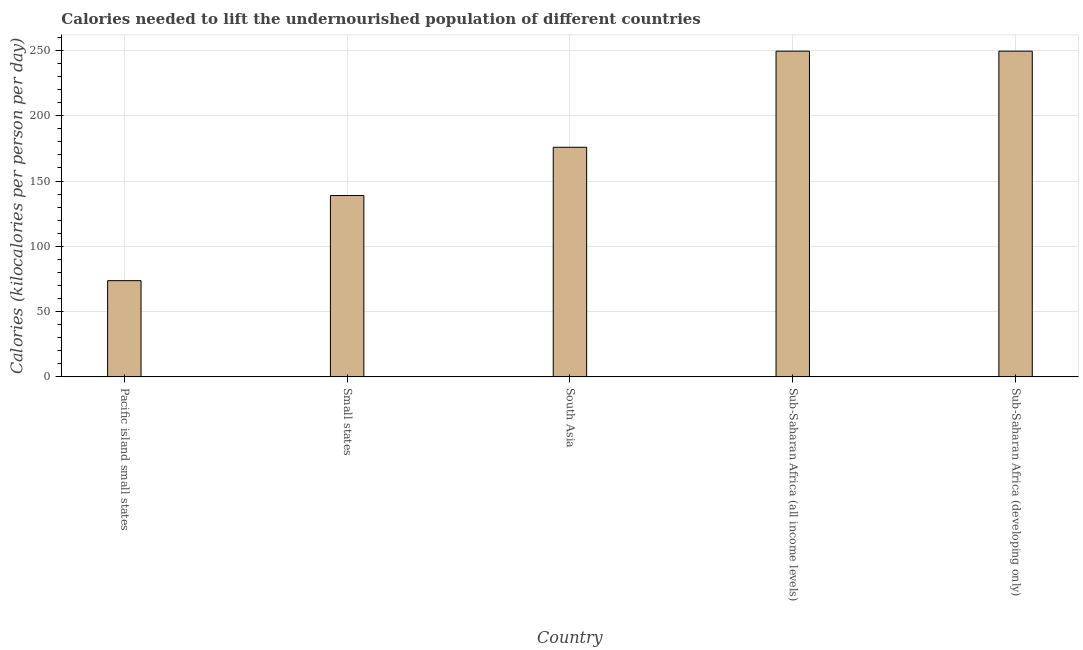Does the graph contain grids?
Your answer should be very brief. Yes. What is the title of the graph?
Your answer should be compact. Calories needed to lift the undernourished population of different countries. What is the label or title of the X-axis?
Provide a succinct answer. Country. What is the label or title of the Y-axis?
Offer a very short reply. Calories (kilocalories per person per day). What is the depth of food deficit in Pacific island small states?
Keep it short and to the point. 73.68. Across all countries, what is the maximum depth of food deficit?
Give a very brief answer. 249.45. Across all countries, what is the minimum depth of food deficit?
Give a very brief answer. 73.68. In which country was the depth of food deficit maximum?
Your answer should be compact. Sub-Saharan Africa (all income levels). In which country was the depth of food deficit minimum?
Give a very brief answer. Pacific island small states. What is the sum of the depth of food deficit?
Give a very brief answer. 887.31. What is the difference between the depth of food deficit in Pacific island small states and South Asia?
Provide a succinct answer. -102.16. What is the average depth of food deficit per country?
Give a very brief answer. 177.46. What is the median depth of food deficit?
Your response must be concise. 175.85. What is the ratio of the depth of food deficit in Pacific island small states to that in Sub-Saharan Africa (developing only)?
Offer a very short reply. 0.29. Is the depth of food deficit in South Asia less than that in Sub-Saharan Africa (all income levels)?
Keep it short and to the point. Yes. Is the difference between the depth of food deficit in Small states and Sub-Saharan Africa (developing only) greater than the difference between any two countries?
Keep it short and to the point. No. What is the difference between the highest and the second highest depth of food deficit?
Offer a terse response. 0. What is the difference between the highest and the lowest depth of food deficit?
Provide a short and direct response. 175.77. In how many countries, is the depth of food deficit greater than the average depth of food deficit taken over all countries?
Your answer should be very brief. 2. How many bars are there?
Make the answer very short. 5. Are all the bars in the graph horizontal?
Your answer should be very brief. No. How many countries are there in the graph?
Keep it short and to the point. 5. What is the difference between two consecutive major ticks on the Y-axis?
Make the answer very short. 50. What is the Calories (kilocalories per person per day) in Pacific island small states?
Your response must be concise. 73.68. What is the Calories (kilocalories per person per day) of Small states?
Provide a short and direct response. 138.88. What is the Calories (kilocalories per person per day) in South Asia?
Your answer should be compact. 175.85. What is the Calories (kilocalories per person per day) in Sub-Saharan Africa (all income levels)?
Your answer should be compact. 249.45. What is the Calories (kilocalories per person per day) in Sub-Saharan Africa (developing only)?
Your answer should be very brief. 249.45. What is the difference between the Calories (kilocalories per person per day) in Pacific island small states and Small states?
Provide a succinct answer. -65.2. What is the difference between the Calories (kilocalories per person per day) in Pacific island small states and South Asia?
Give a very brief answer. -102.16. What is the difference between the Calories (kilocalories per person per day) in Pacific island small states and Sub-Saharan Africa (all income levels)?
Your response must be concise. -175.77. What is the difference between the Calories (kilocalories per person per day) in Pacific island small states and Sub-Saharan Africa (developing only)?
Your response must be concise. -175.77. What is the difference between the Calories (kilocalories per person per day) in Small states and South Asia?
Provide a succinct answer. -36.96. What is the difference between the Calories (kilocalories per person per day) in Small states and Sub-Saharan Africa (all income levels)?
Make the answer very short. -110.57. What is the difference between the Calories (kilocalories per person per day) in Small states and Sub-Saharan Africa (developing only)?
Ensure brevity in your answer.  -110.57. What is the difference between the Calories (kilocalories per person per day) in South Asia and Sub-Saharan Africa (all income levels)?
Your answer should be compact. -73.61. What is the difference between the Calories (kilocalories per person per day) in South Asia and Sub-Saharan Africa (developing only)?
Your answer should be very brief. -73.61. What is the ratio of the Calories (kilocalories per person per day) in Pacific island small states to that in Small states?
Provide a short and direct response. 0.53. What is the ratio of the Calories (kilocalories per person per day) in Pacific island small states to that in South Asia?
Give a very brief answer. 0.42. What is the ratio of the Calories (kilocalories per person per day) in Pacific island small states to that in Sub-Saharan Africa (all income levels)?
Provide a short and direct response. 0.29. What is the ratio of the Calories (kilocalories per person per day) in Pacific island small states to that in Sub-Saharan Africa (developing only)?
Give a very brief answer. 0.29. What is the ratio of the Calories (kilocalories per person per day) in Small states to that in South Asia?
Ensure brevity in your answer.  0.79. What is the ratio of the Calories (kilocalories per person per day) in Small states to that in Sub-Saharan Africa (all income levels)?
Offer a very short reply. 0.56. What is the ratio of the Calories (kilocalories per person per day) in Small states to that in Sub-Saharan Africa (developing only)?
Ensure brevity in your answer.  0.56. What is the ratio of the Calories (kilocalories per person per day) in South Asia to that in Sub-Saharan Africa (all income levels)?
Offer a very short reply. 0.7. What is the ratio of the Calories (kilocalories per person per day) in South Asia to that in Sub-Saharan Africa (developing only)?
Your answer should be compact. 0.7. 